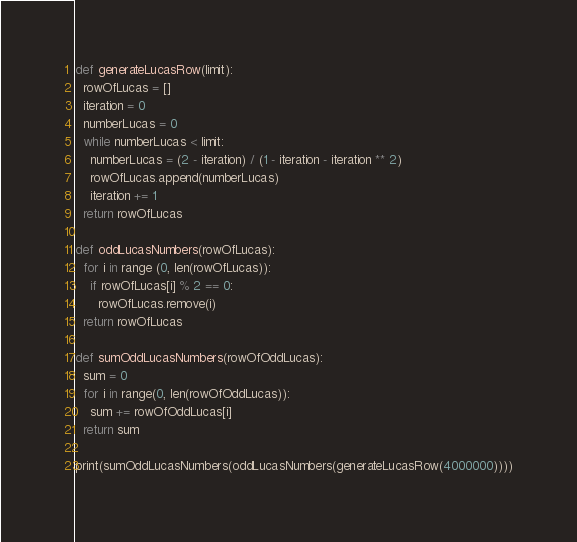Convert code to text. <code><loc_0><loc_0><loc_500><loc_500><_Python_>def generateLucasRow(limit):
  rowOfLucas = []
  iteration = 0
  numberLucas = 0
  while numberLucas < limit:
    numberLucas = (2 - iteration) / (1 - iteration - iteration ** 2)
    rowOfLucas.append(numberLucas)
    iteration += 1
  return rowOfLucas

def oddLucasNumbers(rowOfLucas):
  for i in range (0, len(rowOfLucas)):
    if rowOfLucas[i] % 2 == 0:
      rowOfLucas.remove(i)
  return rowOfLucas

def sumOddLucasNumbers(rowOfOddLucas):
  sum = 0
  for i in range(0, len(rowOfOddLucas)):
    sum += rowOfOddLucas[i]
  return sum

print(sumOddLucasNumbers(oddLucasNumbers(generateLucasRow(4000000))))</code> 